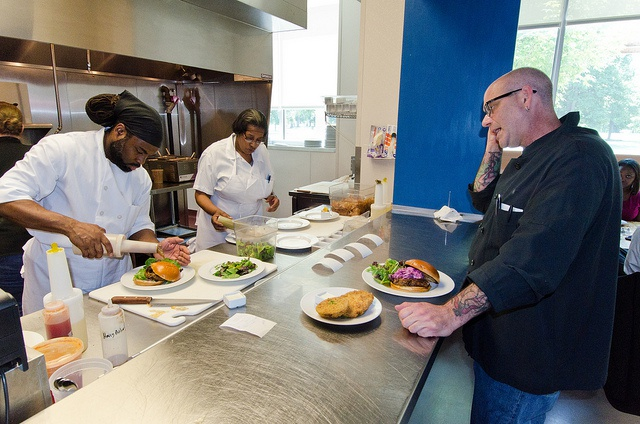Describe the objects in this image and their specific colors. I can see people in tan, black, navy, and gray tones, people in tan, lightgray, darkgray, and black tones, people in tan, darkgray, lightgray, black, and maroon tones, people in tan, black, maroon, and olive tones, and bottle in tan and lightgray tones in this image. 